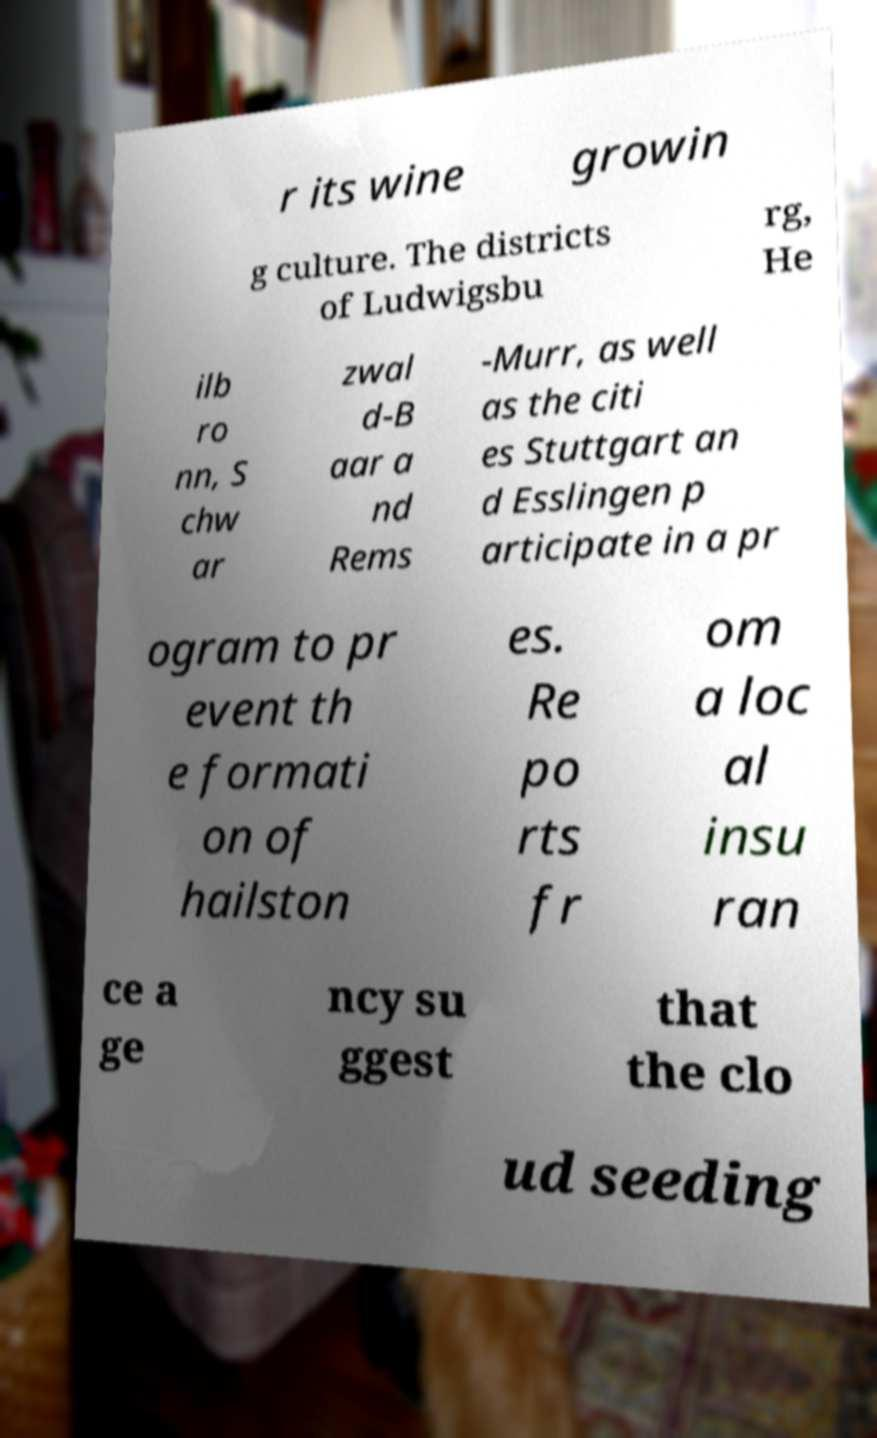Please read and relay the text visible in this image. What does it say? r its wine growin g culture. The districts of Ludwigsbu rg, He ilb ro nn, S chw ar zwal d-B aar a nd Rems -Murr, as well as the citi es Stuttgart an d Esslingen p articipate in a pr ogram to pr event th e formati on of hailston es. Re po rts fr om a loc al insu ran ce a ge ncy su ggest that the clo ud seeding 